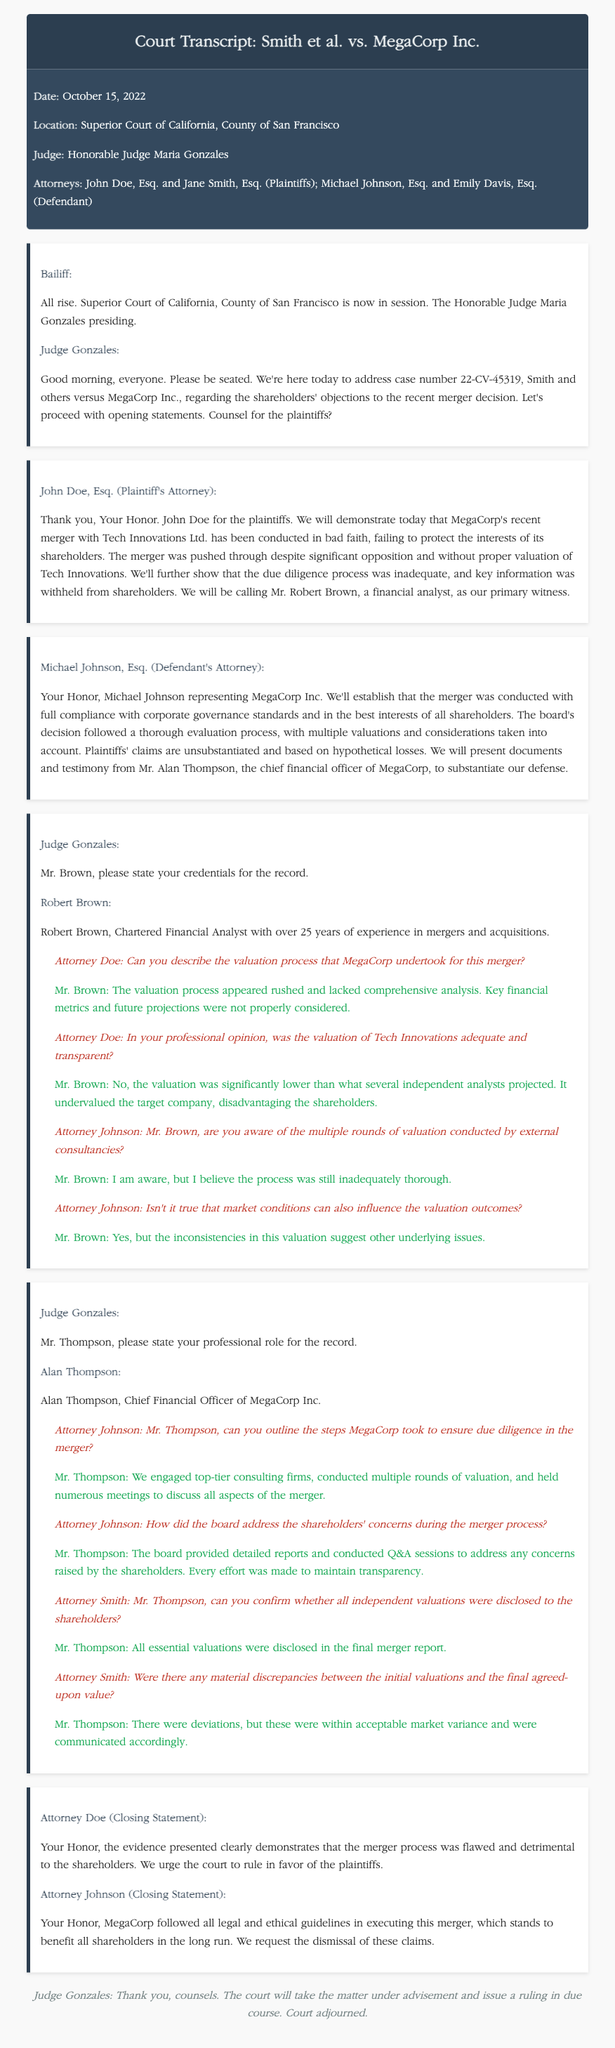What is the case number? The case number is specified at the beginning of the document during the introduction of the hearing.
Answer: 22-CV-45319 Who is the judge presiding over the case? The name of the judge can be found in the information section of the document provided before the hearings begin.
Answer: Honorable Judge Maria Gonzales What is the name of the plaintiff's financial analyst witness? The witness for the plaintiffs is introduced during the testimony section of the document, where their name and credentials are provided.
Answer: Robert Brown What did the plaintiffs claim about the merger process? The plaintiffs' claims highlight specific concerns, which are summarized in the opening statement.
Answer: Conducted in bad faith, inadequate due diligence How many years of experience does Robert Brown have? Robert Brown states his experience directly when asked about his credentials.
Answer: Over 25 years Which attorney represented MegaCorp Inc.? The attorney representing MegaCorp Inc. is identified during their respective opening statement.
Answer: Michael Johnson Did Mr. Thompson confirm the disclosure of valuations to shareholders? This detail is verified in the questioning of Mr. Thompson by the attorney for the plaintiffs.
Answer: Yes What was the response of Attorney Doe about the merger process in closing? Attorney Doe provides a summary of the plaintiffs' position during their closing statement.
Answer: Flawed and detrimental to the shareholders What role does Alan Thompson hold in MegaCorp Inc.? Alan Thompson states his professional role clearly when introduced by the judge.
Answer: Chief Financial Officer 